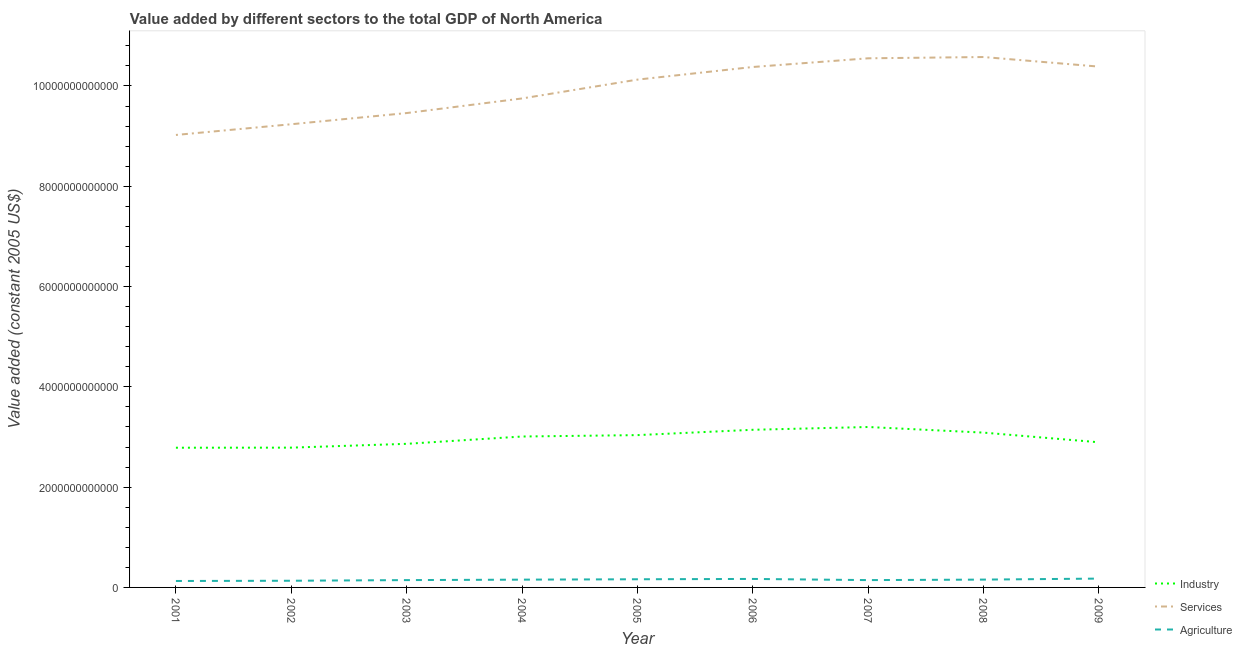Is the number of lines equal to the number of legend labels?
Ensure brevity in your answer.  Yes. What is the value added by services in 2001?
Offer a very short reply. 9.02e+12. Across all years, what is the maximum value added by services?
Make the answer very short. 1.06e+13. Across all years, what is the minimum value added by services?
Provide a short and direct response. 9.02e+12. In which year was the value added by services maximum?
Your answer should be very brief. 2008. In which year was the value added by services minimum?
Give a very brief answer. 2001. What is the total value added by agricultural sector in the graph?
Give a very brief answer. 1.37e+12. What is the difference between the value added by agricultural sector in 2005 and that in 2006?
Keep it short and to the point. -6.64e+09. What is the difference between the value added by agricultural sector in 2008 and the value added by industrial sector in 2009?
Provide a short and direct response. -2.74e+12. What is the average value added by agricultural sector per year?
Keep it short and to the point. 1.53e+11. In the year 2008, what is the difference between the value added by agricultural sector and value added by industrial sector?
Provide a succinct answer. -2.93e+12. What is the ratio of the value added by agricultural sector in 2002 to that in 2009?
Provide a succinct answer. 0.76. Is the value added by agricultural sector in 2001 less than that in 2004?
Give a very brief answer. Yes. What is the difference between the highest and the second highest value added by agricultural sector?
Give a very brief answer. 6.85e+09. What is the difference between the highest and the lowest value added by services?
Offer a terse response. 1.55e+12. Does the value added by industrial sector monotonically increase over the years?
Your answer should be compact. No. Is the value added by services strictly greater than the value added by industrial sector over the years?
Your answer should be compact. Yes. Is the value added by industrial sector strictly less than the value added by agricultural sector over the years?
Give a very brief answer. No. How many years are there in the graph?
Offer a very short reply. 9. What is the difference between two consecutive major ticks on the Y-axis?
Provide a succinct answer. 2.00e+12. Are the values on the major ticks of Y-axis written in scientific E-notation?
Your answer should be compact. No. Where does the legend appear in the graph?
Make the answer very short. Bottom right. How many legend labels are there?
Your answer should be very brief. 3. What is the title of the graph?
Make the answer very short. Value added by different sectors to the total GDP of North America. Does "Ages 50+" appear as one of the legend labels in the graph?
Your response must be concise. No. What is the label or title of the Y-axis?
Your answer should be compact. Value added (constant 2005 US$). What is the Value added (constant 2005 US$) of Industry in 2001?
Offer a terse response. 2.79e+12. What is the Value added (constant 2005 US$) in Services in 2001?
Your response must be concise. 9.02e+12. What is the Value added (constant 2005 US$) of Agriculture in 2001?
Your answer should be compact. 1.28e+11. What is the Value added (constant 2005 US$) in Industry in 2002?
Give a very brief answer. 2.79e+12. What is the Value added (constant 2005 US$) of Services in 2002?
Give a very brief answer. 9.24e+12. What is the Value added (constant 2005 US$) in Agriculture in 2002?
Your answer should be very brief. 1.33e+11. What is the Value added (constant 2005 US$) of Industry in 2003?
Provide a short and direct response. 2.86e+12. What is the Value added (constant 2005 US$) in Services in 2003?
Give a very brief answer. 9.46e+12. What is the Value added (constant 2005 US$) in Agriculture in 2003?
Your answer should be compact. 1.46e+11. What is the Value added (constant 2005 US$) in Industry in 2004?
Provide a short and direct response. 3.01e+12. What is the Value added (constant 2005 US$) of Services in 2004?
Provide a succinct answer. 9.75e+12. What is the Value added (constant 2005 US$) of Agriculture in 2004?
Your answer should be compact. 1.55e+11. What is the Value added (constant 2005 US$) of Industry in 2005?
Offer a very short reply. 3.04e+12. What is the Value added (constant 2005 US$) of Services in 2005?
Your response must be concise. 1.01e+13. What is the Value added (constant 2005 US$) of Agriculture in 2005?
Make the answer very short. 1.63e+11. What is the Value added (constant 2005 US$) of Industry in 2006?
Make the answer very short. 3.14e+12. What is the Value added (constant 2005 US$) of Services in 2006?
Ensure brevity in your answer.  1.04e+13. What is the Value added (constant 2005 US$) in Agriculture in 2006?
Offer a terse response. 1.69e+11. What is the Value added (constant 2005 US$) in Industry in 2007?
Your answer should be very brief. 3.20e+12. What is the Value added (constant 2005 US$) in Services in 2007?
Provide a short and direct response. 1.06e+13. What is the Value added (constant 2005 US$) of Agriculture in 2007?
Give a very brief answer. 1.46e+11. What is the Value added (constant 2005 US$) of Industry in 2008?
Make the answer very short. 3.09e+12. What is the Value added (constant 2005 US$) in Services in 2008?
Offer a very short reply. 1.06e+13. What is the Value added (constant 2005 US$) of Agriculture in 2008?
Your answer should be compact. 1.56e+11. What is the Value added (constant 2005 US$) of Industry in 2009?
Offer a very short reply. 2.89e+12. What is the Value added (constant 2005 US$) in Services in 2009?
Provide a succinct answer. 1.04e+13. What is the Value added (constant 2005 US$) in Agriculture in 2009?
Give a very brief answer. 1.76e+11. Across all years, what is the maximum Value added (constant 2005 US$) in Industry?
Provide a succinct answer. 3.20e+12. Across all years, what is the maximum Value added (constant 2005 US$) in Services?
Your answer should be compact. 1.06e+13. Across all years, what is the maximum Value added (constant 2005 US$) of Agriculture?
Offer a very short reply. 1.76e+11. Across all years, what is the minimum Value added (constant 2005 US$) of Industry?
Your response must be concise. 2.79e+12. Across all years, what is the minimum Value added (constant 2005 US$) in Services?
Make the answer very short. 9.02e+12. Across all years, what is the minimum Value added (constant 2005 US$) in Agriculture?
Provide a short and direct response. 1.28e+11. What is the total Value added (constant 2005 US$) of Industry in the graph?
Offer a terse response. 2.68e+13. What is the total Value added (constant 2005 US$) in Services in the graph?
Offer a very short reply. 8.95e+13. What is the total Value added (constant 2005 US$) of Agriculture in the graph?
Your response must be concise. 1.37e+12. What is the difference between the Value added (constant 2005 US$) in Industry in 2001 and that in 2002?
Keep it short and to the point. -1.61e+09. What is the difference between the Value added (constant 2005 US$) in Services in 2001 and that in 2002?
Your answer should be very brief. -2.14e+11. What is the difference between the Value added (constant 2005 US$) of Agriculture in 2001 and that in 2002?
Offer a very short reply. -4.83e+09. What is the difference between the Value added (constant 2005 US$) of Industry in 2001 and that in 2003?
Offer a very short reply. -7.77e+1. What is the difference between the Value added (constant 2005 US$) of Services in 2001 and that in 2003?
Your answer should be compact. -4.37e+11. What is the difference between the Value added (constant 2005 US$) in Agriculture in 2001 and that in 2003?
Ensure brevity in your answer.  -1.77e+1. What is the difference between the Value added (constant 2005 US$) in Industry in 2001 and that in 2004?
Your response must be concise. -2.23e+11. What is the difference between the Value added (constant 2005 US$) of Services in 2001 and that in 2004?
Keep it short and to the point. -7.28e+11. What is the difference between the Value added (constant 2005 US$) in Agriculture in 2001 and that in 2004?
Provide a short and direct response. -2.69e+1. What is the difference between the Value added (constant 2005 US$) in Industry in 2001 and that in 2005?
Provide a short and direct response. -2.51e+11. What is the difference between the Value added (constant 2005 US$) of Services in 2001 and that in 2005?
Keep it short and to the point. -1.10e+12. What is the difference between the Value added (constant 2005 US$) in Agriculture in 2001 and that in 2005?
Give a very brief answer. -3.43e+1. What is the difference between the Value added (constant 2005 US$) of Industry in 2001 and that in 2006?
Make the answer very short. -3.58e+11. What is the difference between the Value added (constant 2005 US$) of Services in 2001 and that in 2006?
Your answer should be very brief. -1.36e+12. What is the difference between the Value added (constant 2005 US$) in Agriculture in 2001 and that in 2006?
Your answer should be compact. -4.10e+1. What is the difference between the Value added (constant 2005 US$) in Industry in 2001 and that in 2007?
Give a very brief answer. -4.13e+11. What is the difference between the Value added (constant 2005 US$) of Services in 2001 and that in 2007?
Your answer should be compact. -1.53e+12. What is the difference between the Value added (constant 2005 US$) in Agriculture in 2001 and that in 2007?
Make the answer very short. -1.78e+1. What is the difference between the Value added (constant 2005 US$) of Industry in 2001 and that in 2008?
Your answer should be very brief. -3.01e+11. What is the difference between the Value added (constant 2005 US$) in Services in 2001 and that in 2008?
Offer a very short reply. -1.55e+12. What is the difference between the Value added (constant 2005 US$) of Agriculture in 2001 and that in 2008?
Offer a very short reply. -2.77e+1. What is the difference between the Value added (constant 2005 US$) in Industry in 2001 and that in 2009?
Your response must be concise. -1.09e+11. What is the difference between the Value added (constant 2005 US$) in Services in 2001 and that in 2009?
Make the answer very short. -1.36e+12. What is the difference between the Value added (constant 2005 US$) in Agriculture in 2001 and that in 2009?
Your response must be concise. -4.78e+1. What is the difference between the Value added (constant 2005 US$) of Industry in 2002 and that in 2003?
Keep it short and to the point. -7.61e+1. What is the difference between the Value added (constant 2005 US$) of Services in 2002 and that in 2003?
Offer a terse response. -2.23e+11. What is the difference between the Value added (constant 2005 US$) in Agriculture in 2002 and that in 2003?
Your response must be concise. -1.29e+1. What is the difference between the Value added (constant 2005 US$) in Industry in 2002 and that in 2004?
Keep it short and to the point. -2.22e+11. What is the difference between the Value added (constant 2005 US$) in Services in 2002 and that in 2004?
Give a very brief answer. -5.14e+11. What is the difference between the Value added (constant 2005 US$) in Agriculture in 2002 and that in 2004?
Keep it short and to the point. -2.20e+1. What is the difference between the Value added (constant 2005 US$) of Industry in 2002 and that in 2005?
Keep it short and to the point. -2.50e+11. What is the difference between the Value added (constant 2005 US$) in Services in 2002 and that in 2005?
Ensure brevity in your answer.  -8.90e+11. What is the difference between the Value added (constant 2005 US$) in Agriculture in 2002 and that in 2005?
Offer a very short reply. -2.95e+1. What is the difference between the Value added (constant 2005 US$) of Industry in 2002 and that in 2006?
Provide a succinct answer. -3.56e+11. What is the difference between the Value added (constant 2005 US$) of Services in 2002 and that in 2006?
Give a very brief answer. -1.14e+12. What is the difference between the Value added (constant 2005 US$) of Agriculture in 2002 and that in 2006?
Provide a succinct answer. -3.61e+1. What is the difference between the Value added (constant 2005 US$) in Industry in 2002 and that in 2007?
Your answer should be very brief. -4.12e+11. What is the difference between the Value added (constant 2005 US$) of Services in 2002 and that in 2007?
Offer a terse response. -1.31e+12. What is the difference between the Value added (constant 2005 US$) of Agriculture in 2002 and that in 2007?
Give a very brief answer. -1.29e+1. What is the difference between the Value added (constant 2005 US$) of Industry in 2002 and that in 2008?
Offer a terse response. -3.00e+11. What is the difference between the Value added (constant 2005 US$) in Services in 2002 and that in 2008?
Give a very brief answer. -1.34e+12. What is the difference between the Value added (constant 2005 US$) in Agriculture in 2002 and that in 2008?
Give a very brief answer. -2.28e+1. What is the difference between the Value added (constant 2005 US$) in Industry in 2002 and that in 2009?
Offer a very short reply. -1.07e+11. What is the difference between the Value added (constant 2005 US$) of Services in 2002 and that in 2009?
Offer a terse response. -1.15e+12. What is the difference between the Value added (constant 2005 US$) in Agriculture in 2002 and that in 2009?
Your response must be concise. -4.30e+1. What is the difference between the Value added (constant 2005 US$) in Industry in 2003 and that in 2004?
Keep it short and to the point. -1.46e+11. What is the difference between the Value added (constant 2005 US$) of Services in 2003 and that in 2004?
Make the answer very short. -2.91e+11. What is the difference between the Value added (constant 2005 US$) of Agriculture in 2003 and that in 2004?
Offer a very short reply. -9.17e+09. What is the difference between the Value added (constant 2005 US$) in Industry in 2003 and that in 2005?
Offer a terse response. -1.74e+11. What is the difference between the Value added (constant 2005 US$) of Services in 2003 and that in 2005?
Make the answer very short. -6.67e+11. What is the difference between the Value added (constant 2005 US$) of Agriculture in 2003 and that in 2005?
Offer a very short reply. -1.66e+1. What is the difference between the Value added (constant 2005 US$) of Industry in 2003 and that in 2006?
Your answer should be compact. -2.80e+11. What is the difference between the Value added (constant 2005 US$) of Services in 2003 and that in 2006?
Your answer should be very brief. -9.19e+11. What is the difference between the Value added (constant 2005 US$) of Agriculture in 2003 and that in 2006?
Provide a short and direct response. -2.33e+1. What is the difference between the Value added (constant 2005 US$) in Industry in 2003 and that in 2007?
Your answer should be compact. -3.36e+11. What is the difference between the Value added (constant 2005 US$) of Services in 2003 and that in 2007?
Provide a succinct answer. -1.09e+12. What is the difference between the Value added (constant 2005 US$) of Agriculture in 2003 and that in 2007?
Offer a very short reply. -6.44e+07. What is the difference between the Value added (constant 2005 US$) of Industry in 2003 and that in 2008?
Give a very brief answer. -2.24e+11. What is the difference between the Value added (constant 2005 US$) in Services in 2003 and that in 2008?
Ensure brevity in your answer.  -1.12e+12. What is the difference between the Value added (constant 2005 US$) in Agriculture in 2003 and that in 2008?
Provide a succinct answer. -9.98e+09. What is the difference between the Value added (constant 2005 US$) in Industry in 2003 and that in 2009?
Your answer should be very brief. -3.10e+1. What is the difference between the Value added (constant 2005 US$) in Services in 2003 and that in 2009?
Offer a terse response. -9.26e+11. What is the difference between the Value added (constant 2005 US$) in Agriculture in 2003 and that in 2009?
Make the answer very short. -3.01e+1. What is the difference between the Value added (constant 2005 US$) of Industry in 2004 and that in 2005?
Make the answer very short. -2.79e+1. What is the difference between the Value added (constant 2005 US$) of Services in 2004 and that in 2005?
Keep it short and to the point. -3.76e+11. What is the difference between the Value added (constant 2005 US$) in Agriculture in 2004 and that in 2005?
Your answer should be very brief. -7.46e+09. What is the difference between the Value added (constant 2005 US$) of Industry in 2004 and that in 2006?
Offer a very short reply. -1.34e+11. What is the difference between the Value added (constant 2005 US$) in Services in 2004 and that in 2006?
Make the answer very short. -6.27e+11. What is the difference between the Value added (constant 2005 US$) in Agriculture in 2004 and that in 2006?
Ensure brevity in your answer.  -1.41e+1. What is the difference between the Value added (constant 2005 US$) of Industry in 2004 and that in 2007?
Your answer should be very brief. -1.90e+11. What is the difference between the Value added (constant 2005 US$) in Services in 2004 and that in 2007?
Ensure brevity in your answer.  -8.01e+11. What is the difference between the Value added (constant 2005 US$) of Agriculture in 2004 and that in 2007?
Your answer should be very brief. 9.11e+09. What is the difference between the Value added (constant 2005 US$) of Industry in 2004 and that in 2008?
Your response must be concise. -7.78e+1. What is the difference between the Value added (constant 2005 US$) in Services in 2004 and that in 2008?
Offer a very short reply. -8.26e+11. What is the difference between the Value added (constant 2005 US$) in Agriculture in 2004 and that in 2008?
Offer a terse response. -8.08e+08. What is the difference between the Value added (constant 2005 US$) in Industry in 2004 and that in 2009?
Give a very brief answer. 1.15e+11. What is the difference between the Value added (constant 2005 US$) in Services in 2004 and that in 2009?
Ensure brevity in your answer.  -6.35e+11. What is the difference between the Value added (constant 2005 US$) of Agriculture in 2004 and that in 2009?
Your answer should be very brief. -2.09e+1. What is the difference between the Value added (constant 2005 US$) of Industry in 2005 and that in 2006?
Offer a terse response. -1.06e+11. What is the difference between the Value added (constant 2005 US$) of Services in 2005 and that in 2006?
Give a very brief answer. -2.52e+11. What is the difference between the Value added (constant 2005 US$) in Agriculture in 2005 and that in 2006?
Your answer should be very brief. -6.64e+09. What is the difference between the Value added (constant 2005 US$) of Industry in 2005 and that in 2007?
Make the answer very short. -1.62e+11. What is the difference between the Value added (constant 2005 US$) in Services in 2005 and that in 2007?
Offer a terse response. -4.25e+11. What is the difference between the Value added (constant 2005 US$) in Agriculture in 2005 and that in 2007?
Your response must be concise. 1.66e+1. What is the difference between the Value added (constant 2005 US$) in Industry in 2005 and that in 2008?
Your answer should be compact. -5.00e+1. What is the difference between the Value added (constant 2005 US$) of Services in 2005 and that in 2008?
Offer a very short reply. -4.51e+11. What is the difference between the Value added (constant 2005 US$) of Agriculture in 2005 and that in 2008?
Your answer should be very brief. 6.65e+09. What is the difference between the Value added (constant 2005 US$) in Industry in 2005 and that in 2009?
Your answer should be very brief. 1.43e+11. What is the difference between the Value added (constant 2005 US$) of Services in 2005 and that in 2009?
Offer a terse response. -2.60e+11. What is the difference between the Value added (constant 2005 US$) of Agriculture in 2005 and that in 2009?
Your response must be concise. -1.35e+1. What is the difference between the Value added (constant 2005 US$) in Industry in 2006 and that in 2007?
Give a very brief answer. -5.56e+1. What is the difference between the Value added (constant 2005 US$) in Services in 2006 and that in 2007?
Your response must be concise. -1.73e+11. What is the difference between the Value added (constant 2005 US$) in Agriculture in 2006 and that in 2007?
Make the answer very short. 2.32e+1. What is the difference between the Value added (constant 2005 US$) of Industry in 2006 and that in 2008?
Provide a short and direct response. 5.63e+1. What is the difference between the Value added (constant 2005 US$) of Services in 2006 and that in 2008?
Provide a short and direct response. -1.99e+11. What is the difference between the Value added (constant 2005 US$) in Agriculture in 2006 and that in 2008?
Offer a very short reply. 1.33e+1. What is the difference between the Value added (constant 2005 US$) in Industry in 2006 and that in 2009?
Provide a short and direct response. 2.49e+11. What is the difference between the Value added (constant 2005 US$) of Services in 2006 and that in 2009?
Your answer should be very brief. -7.72e+09. What is the difference between the Value added (constant 2005 US$) in Agriculture in 2006 and that in 2009?
Offer a terse response. -6.85e+09. What is the difference between the Value added (constant 2005 US$) of Industry in 2007 and that in 2008?
Your response must be concise. 1.12e+11. What is the difference between the Value added (constant 2005 US$) in Services in 2007 and that in 2008?
Give a very brief answer. -2.54e+1. What is the difference between the Value added (constant 2005 US$) of Agriculture in 2007 and that in 2008?
Offer a very short reply. -9.92e+09. What is the difference between the Value added (constant 2005 US$) in Industry in 2007 and that in 2009?
Make the answer very short. 3.05e+11. What is the difference between the Value added (constant 2005 US$) of Services in 2007 and that in 2009?
Provide a short and direct response. 1.66e+11. What is the difference between the Value added (constant 2005 US$) in Agriculture in 2007 and that in 2009?
Provide a succinct answer. -3.01e+1. What is the difference between the Value added (constant 2005 US$) in Industry in 2008 and that in 2009?
Your answer should be very brief. 1.93e+11. What is the difference between the Value added (constant 2005 US$) in Services in 2008 and that in 2009?
Offer a terse response. 1.91e+11. What is the difference between the Value added (constant 2005 US$) of Agriculture in 2008 and that in 2009?
Provide a succinct answer. -2.01e+1. What is the difference between the Value added (constant 2005 US$) of Industry in 2001 and the Value added (constant 2005 US$) of Services in 2002?
Keep it short and to the point. -6.45e+12. What is the difference between the Value added (constant 2005 US$) in Industry in 2001 and the Value added (constant 2005 US$) in Agriculture in 2002?
Ensure brevity in your answer.  2.65e+12. What is the difference between the Value added (constant 2005 US$) in Services in 2001 and the Value added (constant 2005 US$) in Agriculture in 2002?
Provide a short and direct response. 8.89e+12. What is the difference between the Value added (constant 2005 US$) in Industry in 2001 and the Value added (constant 2005 US$) in Services in 2003?
Your response must be concise. -6.67e+12. What is the difference between the Value added (constant 2005 US$) in Industry in 2001 and the Value added (constant 2005 US$) in Agriculture in 2003?
Make the answer very short. 2.64e+12. What is the difference between the Value added (constant 2005 US$) of Services in 2001 and the Value added (constant 2005 US$) of Agriculture in 2003?
Provide a short and direct response. 8.88e+12. What is the difference between the Value added (constant 2005 US$) in Industry in 2001 and the Value added (constant 2005 US$) in Services in 2004?
Provide a short and direct response. -6.97e+12. What is the difference between the Value added (constant 2005 US$) of Industry in 2001 and the Value added (constant 2005 US$) of Agriculture in 2004?
Keep it short and to the point. 2.63e+12. What is the difference between the Value added (constant 2005 US$) in Services in 2001 and the Value added (constant 2005 US$) in Agriculture in 2004?
Your answer should be very brief. 8.87e+12. What is the difference between the Value added (constant 2005 US$) of Industry in 2001 and the Value added (constant 2005 US$) of Services in 2005?
Ensure brevity in your answer.  -7.34e+12. What is the difference between the Value added (constant 2005 US$) of Industry in 2001 and the Value added (constant 2005 US$) of Agriculture in 2005?
Your answer should be very brief. 2.62e+12. What is the difference between the Value added (constant 2005 US$) in Services in 2001 and the Value added (constant 2005 US$) in Agriculture in 2005?
Ensure brevity in your answer.  8.86e+12. What is the difference between the Value added (constant 2005 US$) of Industry in 2001 and the Value added (constant 2005 US$) of Services in 2006?
Give a very brief answer. -7.59e+12. What is the difference between the Value added (constant 2005 US$) in Industry in 2001 and the Value added (constant 2005 US$) in Agriculture in 2006?
Your answer should be compact. 2.62e+12. What is the difference between the Value added (constant 2005 US$) in Services in 2001 and the Value added (constant 2005 US$) in Agriculture in 2006?
Offer a terse response. 8.85e+12. What is the difference between the Value added (constant 2005 US$) in Industry in 2001 and the Value added (constant 2005 US$) in Services in 2007?
Provide a short and direct response. -7.77e+12. What is the difference between the Value added (constant 2005 US$) in Industry in 2001 and the Value added (constant 2005 US$) in Agriculture in 2007?
Offer a very short reply. 2.64e+12. What is the difference between the Value added (constant 2005 US$) in Services in 2001 and the Value added (constant 2005 US$) in Agriculture in 2007?
Your answer should be compact. 8.88e+12. What is the difference between the Value added (constant 2005 US$) in Industry in 2001 and the Value added (constant 2005 US$) in Services in 2008?
Your answer should be very brief. -7.79e+12. What is the difference between the Value added (constant 2005 US$) in Industry in 2001 and the Value added (constant 2005 US$) in Agriculture in 2008?
Offer a terse response. 2.63e+12. What is the difference between the Value added (constant 2005 US$) of Services in 2001 and the Value added (constant 2005 US$) of Agriculture in 2008?
Offer a terse response. 8.87e+12. What is the difference between the Value added (constant 2005 US$) in Industry in 2001 and the Value added (constant 2005 US$) in Services in 2009?
Give a very brief answer. -7.60e+12. What is the difference between the Value added (constant 2005 US$) in Industry in 2001 and the Value added (constant 2005 US$) in Agriculture in 2009?
Make the answer very short. 2.61e+12. What is the difference between the Value added (constant 2005 US$) in Services in 2001 and the Value added (constant 2005 US$) in Agriculture in 2009?
Make the answer very short. 8.85e+12. What is the difference between the Value added (constant 2005 US$) of Industry in 2002 and the Value added (constant 2005 US$) of Services in 2003?
Ensure brevity in your answer.  -6.67e+12. What is the difference between the Value added (constant 2005 US$) in Industry in 2002 and the Value added (constant 2005 US$) in Agriculture in 2003?
Keep it short and to the point. 2.64e+12. What is the difference between the Value added (constant 2005 US$) in Services in 2002 and the Value added (constant 2005 US$) in Agriculture in 2003?
Your answer should be very brief. 9.09e+12. What is the difference between the Value added (constant 2005 US$) in Industry in 2002 and the Value added (constant 2005 US$) in Services in 2004?
Make the answer very short. -6.96e+12. What is the difference between the Value added (constant 2005 US$) of Industry in 2002 and the Value added (constant 2005 US$) of Agriculture in 2004?
Make the answer very short. 2.63e+12. What is the difference between the Value added (constant 2005 US$) of Services in 2002 and the Value added (constant 2005 US$) of Agriculture in 2004?
Your response must be concise. 9.08e+12. What is the difference between the Value added (constant 2005 US$) of Industry in 2002 and the Value added (constant 2005 US$) of Services in 2005?
Your response must be concise. -7.34e+12. What is the difference between the Value added (constant 2005 US$) of Industry in 2002 and the Value added (constant 2005 US$) of Agriculture in 2005?
Offer a terse response. 2.63e+12. What is the difference between the Value added (constant 2005 US$) of Services in 2002 and the Value added (constant 2005 US$) of Agriculture in 2005?
Keep it short and to the point. 9.07e+12. What is the difference between the Value added (constant 2005 US$) of Industry in 2002 and the Value added (constant 2005 US$) of Services in 2006?
Ensure brevity in your answer.  -7.59e+12. What is the difference between the Value added (constant 2005 US$) in Industry in 2002 and the Value added (constant 2005 US$) in Agriculture in 2006?
Ensure brevity in your answer.  2.62e+12. What is the difference between the Value added (constant 2005 US$) of Services in 2002 and the Value added (constant 2005 US$) of Agriculture in 2006?
Provide a succinct answer. 9.07e+12. What is the difference between the Value added (constant 2005 US$) in Industry in 2002 and the Value added (constant 2005 US$) in Services in 2007?
Give a very brief answer. -7.76e+12. What is the difference between the Value added (constant 2005 US$) of Industry in 2002 and the Value added (constant 2005 US$) of Agriculture in 2007?
Make the answer very short. 2.64e+12. What is the difference between the Value added (constant 2005 US$) of Services in 2002 and the Value added (constant 2005 US$) of Agriculture in 2007?
Offer a terse response. 9.09e+12. What is the difference between the Value added (constant 2005 US$) in Industry in 2002 and the Value added (constant 2005 US$) in Services in 2008?
Offer a very short reply. -7.79e+12. What is the difference between the Value added (constant 2005 US$) of Industry in 2002 and the Value added (constant 2005 US$) of Agriculture in 2008?
Your answer should be very brief. 2.63e+12. What is the difference between the Value added (constant 2005 US$) of Services in 2002 and the Value added (constant 2005 US$) of Agriculture in 2008?
Offer a terse response. 9.08e+12. What is the difference between the Value added (constant 2005 US$) in Industry in 2002 and the Value added (constant 2005 US$) in Services in 2009?
Your answer should be very brief. -7.60e+12. What is the difference between the Value added (constant 2005 US$) of Industry in 2002 and the Value added (constant 2005 US$) of Agriculture in 2009?
Your response must be concise. 2.61e+12. What is the difference between the Value added (constant 2005 US$) of Services in 2002 and the Value added (constant 2005 US$) of Agriculture in 2009?
Keep it short and to the point. 9.06e+12. What is the difference between the Value added (constant 2005 US$) of Industry in 2003 and the Value added (constant 2005 US$) of Services in 2004?
Offer a very short reply. -6.89e+12. What is the difference between the Value added (constant 2005 US$) of Industry in 2003 and the Value added (constant 2005 US$) of Agriculture in 2004?
Offer a terse response. 2.71e+12. What is the difference between the Value added (constant 2005 US$) in Services in 2003 and the Value added (constant 2005 US$) in Agriculture in 2004?
Offer a terse response. 9.30e+12. What is the difference between the Value added (constant 2005 US$) in Industry in 2003 and the Value added (constant 2005 US$) in Services in 2005?
Offer a very short reply. -7.26e+12. What is the difference between the Value added (constant 2005 US$) of Industry in 2003 and the Value added (constant 2005 US$) of Agriculture in 2005?
Keep it short and to the point. 2.70e+12. What is the difference between the Value added (constant 2005 US$) of Services in 2003 and the Value added (constant 2005 US$) of Agriculture in 2005?
Make the answer very short. 9.30e+12. What is the difference between the Value added (constant 2005 US$) of Industry in 2003 and the Value added (constant 2005 US$) of Services in 2006?
Provide a succinct answer. -7.51e+12. What is the difference between the Value added (constant 2005 US$) of Industry in 2003 and the Value added (constant 2005 US$) of Agriculture in 2006?
Offer a terse response. 2.69e+12. What is the difference between the Value added (constant 2005 US$) of Services in 2003 and the Value added (constant 2005 US$) of Agriculture in 2006?
Offer a terse response. 9.29e+12. What is the difference between the Value added (constant 2005 US$) in Industry in 2003 and the Value added (constant 2005 US$) in Services in 2007?
Ensure brevity in your answer.  -7.69e+12. What is the difference between the Value added (constant 2005 US$) of Industry in 2003 and the Value added (constant 2005 US$) of Agriculture in 2007?
Give a very brief answer. 2.72e+12. What is the difference between the Value added (constant 2005 US$) in Services in 2003 and the Value added (constant 2005 US$) in Agriculture in 2007?
Make the answer very short. 9.31e+12. What is the difference between the Value added (constant 2005 US$) of Industry in 2003 and the Value added (constant 2005 US$) of Services in 2008?
Your response must be concise. -7.71e+12. What is the difference between the Value added (constant 2005 US$) of Industry in 2003 and the Value added (constant 2005 US$) of Agriculture in 2008?
Your answer should be very brief. 2.71e+12. What is the difference between the Value added (constant 2005 US$) of Services in 2003 and the Value added (constant 2005 US$) of Agriculture in 2008?
Your answer should be very brief. 9.30e+12. What is the difference between the Value added (constant 2005 US$) of Industry in 2003 and the Value added (constant 2005 US$) of Services in 2009?
Provide a succinct answer. -7.52e+12. What is the difference between the Value added (constant 2005 US$) in Industry in 2003 and the Value added (constant 2005 US$) in Agriculture in 2009?
Provide a short and direct response. 2.69e+12. What is the difference between the Value added (constant 2005 US$) of Services in 2003 and the Value added (constant 2005 US$) of Agriculture in 2009?
Offer a terse response. 9.28e+12. What is the difference between the Value added (constant 2005 US$) in Industry in 2004 and the Value added (constant 2005 US$) in Services in 2005?
Your response must be concise. -7.12e+12. What is the difference between the Value added (constant 2005 US$) of Industry in 2004 and the Value added (constant 2005 US$) of Agriculture in 2005?
Provide a succinct answer. 2.85e+12. What is the difference between the Value added (constant 2005 US$) of Services in 2004 and the Value added (constant 2005 US$) of Agriculture in 2005?
Keep it short and to the point. 9.59e+12. What is the difference between the Value added (constant 2005 US$) in Industry in 2004 and the Value added (constant 2005 US$) in Services in 2006?
Your response must be concise. -7.37e+12. What is the difference between the Value added (constant 2005 US$) of Industry in 2004 and the Value added (constant 2005 US$) of Agriculture in 2006?
Ensure brevity in your answer.  2.84e+12. What is the difference between the Value added (constant 2005 US$) in Services in 2004 and the Value added (constant 2005 US$) in Agriculture in 2006?
Your response must be concise. 9.58e+12. What is the difference between the Value added (constant 2005 US$) in Industry in 2004 and the Value added (constant 2005 US$) in Services in 2007?
Give a very brief answer. -7.54e+12. What is the difference between the Value added (constant 2005 US$) in Industry in 2004 and the Value added (constant 2005 US$) in Agriculture in 2007?
Offer a very short reply. 2.86e+12. What is the difference between the Value added (constant 2005 US$) in Services in 2004 and the Value added (constant 2005 US$) in Agriculture in 2007?
Your answer should be very brief. 9.61e+12. What is the difference between the Value added (constant 2005 US$) in Industry in 2004 and the Value added (constant 2005 US$) in Services in 2008?
Offer a terse response. -7.57e+12. What is the difference between the Value added (constant 2005 US$) of Industry in 2004 and the Value added (constant 2005 US$) of Agriculture in 2008?
Your response must be concise. 2.85e+12. What is the difference between the Value added (constant 2005 US$) in Services in 2004 and the Value added (constant 2005 US$) in Agriculture in 2008?
Give a very brief answer. 9.60e+12. What is the difference between the Value added (constant 2005 US$) in Industry in 2004 and the Value added (constant 2005 US$) in Services in 2009?
Make the answer very short. -7.38e+12. What is the difference between the Value added (constant 2005 US$) in Industry in 2004 and the Value added (constant 2005 US$) in Agriculture in 2009?
Ensure brevity in your answer.  2.83e+12. What is the difference between the Value added (constant 2005 US$) in Services in 2004 and the Value added (constant 2005 US$) in Agriculture in 2009?
Your answer should be compact. 9.58e+12. What is the difference between the Value added (constant 2005 US$) in Industry in 2005 and the Value added (constant 2005 US$) in Services in 2006?
Keep it short and to the point. -7.34e+12. What is the difference between the Value added (constant 2005 US$) in Industry in 2005 and the Value added (constant 2005 US$) in Agriculture in 2006?
Ensure brevity in your answer.  2.87e+12. What is the difference between the Value added (constant 2005 US$) in Services in 2005 and the Value added (constant 2005 US$) in Agriculture in 2006?
Your response must be concise. 9.96e+12. What is the difference between the Value added (constant 2005 US$) in Industry in 2005 and the Value added (constant 2005 US$) in Services in 2007?
Offer a very short reply. -7.51e+12. What is the difference between the Value added (constant 2005 US$) in Industry in 2005 and the Value added (constant 2005 US$) in Agriculture in 2007?
Provide a short and direct response. 2.89e+12. What is the difference between the Value added (constant 2005 US$) of Services in 2005 and the Value added (constant 2005 US$) of Agriculture in 2007?
Provide a succinct answer. 9.98e+12. What is the difference between the Value added (constant 2005 US$) of Industry in 2005 and the Value added (constant 2005 US$) of Services in 2008?
Keep it short and to the point. -7.54e+12. What is the difference between the Value added (constant 2005 US$) in Industry in 2005 and the Value added (constant 2005 US$) in Agriculture in 2008?
Ensure brevity in your answer.  2.88e+12. What is the difference between the Value added (constant 2005 US$) of Services in 2005 and the Value added (constant 2005 US$) of Agriculture in 2008?
Ensure brevity in your answer.  9.97e+12. What is the difference between the Value added (constant 2005 US$) in Industry in 2005 and the Value added (constant 2005 US$) in Services in 2009?
Ensure brevity in your answer.  -7.35e+12. What is the difference between the Value added (constant 2005 US$) in Industry in 2005 and the Value added (constant 2005 US$) in Agriculture in 2009?
Offer a very short reply. 2.86e+12. What is the difference between the Value added (constant 2005 US$) in Services in 2005 and the Value added (constant 2005 US$) in Agriculture in 2009?
Provide a short and direct response. 9.95e+12. What is the difference between the Value added (constant 2005 US$) of Industry in 2006 and the Value added (constant 2005 US$) of Services in 2007?
Give a very brief answer. -7.41e+12. What is the difference between the Value added (constant 2005 US$) of Industry in 2006 and the Value added (constant 2005 US$) of Agriculture in 2007?
Ensure brevity in your answer.  3.00e+12. What is the difference between the Value added (constant 2005 US$) of Services in 2006 and the Value added (constant 2005 US$) of Agriculture in 2007?
Ensure brevity in your answer.  1.02e+13. What is the difference between the Value added (constant 2005 US$) in Industry in 2006 and the Value added (constant 2005 US$) in Services in 2008?
Give a very brief answer. -7.43e+12. What is the difference between the Value added (constant 2005 US$) in Industry in 2006 and the Value added (constant 2005 US$) in Agriculture in 2008?
Keep it short and to the point. 2.99e+12. What is the difference between the Value added (constant 2005 US$) of Services in 2006 and the Value added (constant 2005 US$) of Agriculture in 2008?
Offer a very short reply. 1.02e+13. What is the difference between the Value added (constant 2005 US$) of Industry in 2006 and the Value added (constant 2005 US$) of Services in 2009?
Your answer should be compact. -7.24e+12. What is the difference between the Value added (constant 2005 US$) in Industry in 2006 and the Value added (constant 2005 US$) in Agriculture in 2009?
Keep it short and to the point. 2.97e+12. What is the difference between the Value added (constant 2005 US$) in Services in 2006 and the Value added (constant 2005 US$) in Agriculture in 2009?
Make the answer very short. 1.02e+13. What is the difference between the Value added (constant 2005 US$) in Industry in 2007 and the Value added (constant 2005 US$) in Services in 2008?
Give a very brief answer. -7.38e+12. What is the difference between the Value added (constant 2005 US$) in Industry in 2007 and the Value added (constant 2005 US$) in Agriculture in 2008?
Give a very brief answer. 3.04e+12. What is the difference between the Value added (constant 2005 US$) in Services in 2007 and the Value added (constant 2005 US$) in Agriculture in 2008?
Make the answer very short. 1.04e+13. What is the difference between the Value added (constant 2005 US$) in Industry in 2007 and the Value added (constant 2005 US$) in Services in 2009?
Provide a succinct answer. -7.19e+12. What is the difference between the Value added (constant 2005 US$) of Industry in 2007 and the Value added (constant 2005 US$) of Agriculture in 2009?
Offer a very short reply. 3.02e+12. What is the difference between the Value added (constant 2005 US$) of Services in 2007 and the Value added (constant 2005 US$) of Agriculture in 2009?
Make the answer very short. 1.04e+13. What is the difference between the Value added (constant 2005 US$) in Industry in 2008 and the Value added (constant 2005 US$) in Services in 2009?
Offer a terse response. -7.30e+12. What is the difference between the Value added (constant 2005 US$) in Industry in 2008 and the Value added (constant 2005 US$) in Agriculture in 2009?
Provide a succinct answer. 2.91e+12. What is the difference between the Value added (constant 2005 US$) in Services in 2008 and the Value added (constant 2005 US$) in Agriculture in 2009?
Ensure brevity in your answer.  1.04e+13. What is the average Value added (constant 2005 US$) of Industry per year?
Keep it short and to the point. 2.98e+12. What is the average Value added (constant 2005 US$) of Services per year?
Your answer should be very brief. 9.94e+12. What is the average Value added (constant 2005 US$) in Agriculture per year?
Ensure brevity in your answer.  1.53e+11. In the year 2001, what is the difference between the Value added (constant 2005 US$) of Industry and Value added (constant 2005 US$) of Services?
Provide a succinct answer. -6.24e+12. In the year 2001, what is the difference between the Value added (constant 2005 US$) in Industry and Value added (constant 2005 US$) in Agriculture?
Ensure brevity in your answer.  2.66e+12. In the year 2001, what is the difference between the Value added (constant 2005 US$) of Services and Value added (constant 2005 US$) of Agriculture?
Make the answer very short. 8.90e+12. In the year 2002, what is the difference between the Value added (constant 2005 US$) in Industry and Value added (constant 2005 US$) in Services?
Provide a short and direct response. -6.45e+12. In the year 2002, what is the difference between the Value added (constant 2005 US$) in Industry and Value added (constant 2005 US$) in Agriculture?
Ensure brevity in your answer.  2.65e+12. In the year 2002, what is the difference between the Value added (constant 2005 US$) of Services and Value added (constant 2005 US$) of Agriculture?
Provide a succinct answer. 9.10e+12. In the year 2003, what is the difference between the Value added (constant 2005 US$) of Industry and Value added (constant 2005 US$) of Services?
Keep it short and to the point. -6.60e+12. In the year 2003, what is the difference between the Value added (constant 2005 US$) in Industry and Value added (constant 2005 US$) in Agriculture?
Your answer should be compact. 2.72e+12. In the year 2003, what is the difference between the Value added (constant 2005 US$) of Services and Value added (constant 2005 US$) of Agriculture?
Your answer should be compact. 9.31e+12. In the year 2004, what is the difference between the Value added (constant 2005 US$) of Industry and Value added (constant 2005 US$) of Services?
Ensure brevity in your answer.  -6.74e+12. In the year 2004, what is the difference between the Value added (constant 2005 US$) in Industry and Value added (constant 2005 US$) in Agriculture?
Offer a terse response. 2.85e+12. In the year 2004, what is the difference between the Value added (constant 2005 US$) in Services and Value added (constant 2005 US$) in Agriculture?
Your answer should be compact. 9.60e+12. In the year 2005, what is the difference between the Value added (constant 2005 US$) in Industry and Value added (constant 2005 US$) in Services?
Give a very brief answer. -7.09e+12. In the year 2005, what is the difference between the Value added (constant 2005 US$) of Industry and Value added (constant 2005 US$) of Agriculture?
Provide a short and direct response. 2.87e+12. In the year 2005, what is the difference between the Value added (constant 2005 US$) of Services and Value added (constant 2005 US$) of Agriculture?
Provide a succinct answer. 9.96e+12. In the year 2006, what is the difference between the Value added (constant 2005 US$) in Industry and Value added (constant 2005 US$) in Services?
Offer a very short reply. -7.24e+12. In the year 2006, what is the difference between the Value added (constant 2005 US$) of Industry and Value added (constant 2005 US$) of Agriculture?
Ensure brevity in your answer.  2.97e+12. In the year 2006, what is the difference between the Value added (constant 2005 US$) in Services and Value added (constant 2005 US$) in Agriculture?
Provide a short and direct response. 1.02e+13. In the year 2007, what is the difference between the Value added (constant 2005 US$) in Industry and Value added (constant 2005 US$) in Services?
Give a very brief answer. -7.35e+12. In the year 2007, what is the difference between the Value added (constant 2005 US$) in Industry and Value added (constant 2005 US$) in Agriculture?
Your response must be concise. 3.05e+12. In the year 2007, what is the difference between the Value added (constant 2005 US$) of Services and Value added (constant 2005 US$) of Agriculture?
Give a very brief answer. 1.04e+13. In the year 2008, what is the difference between the Value added (constant 2005 US$) of Industry and Value added (constant 2005 US$) of Services?
Provide a succinct answer. -7.49e+12. In the year 2008, what is the difference between the Value added (constant 2005 US$) in Industry and Value added (constant 2005 US$) in Agriculture?
Your answer should be compact. 2.93e+12. In the year 2008, what is the difference between the Value added (constant 2005 US$) of Services and Value added (constant 2005 US$) of Agriculture?
Offer a terse response. 1.04e+13. In the year 2009, what is the difference between the Value added (constant 2005 US$) in Industry and Value added (constant 2005 US$) in Services?
Offer a terse response. -7.49e+12. In the year 2009, what is the difference between the Value added (constant 2005 US$) in Industry and Value added (constant 2005 US$) in Agriculture?
Offer a terse response. 2.72e+12. In the year 2009, what is the difference between the Value added (constant 2005 US$) in Services and Value added (constant 2005 US$) in Agriculture?
Provide a succinct answer. 1.02e+13. What is the ratio of the Value added (constant 2005 US$) in Industry in 2001 to that in 2002?
Your answer should be very brief. 1. What is the ratio of the Value added (constant 2005 US$) of Services in 2001 to that in 2002?
Ensure brevity in your answer.  0.98. What is the ratio of the Value added (constant 2005 US$) of Agriculture in 2001 to that in 2002?
Your response must be concise. 0.96. What is the ratio of the Value added (constant 2005 US$) of Industry in 2001 to that in 2003?
Your answer should be very brief. 0.97. What is the ratio of the Value added (constant 2005 US$) of Services in 2001 to that in 2003?
Keep it short and to the point. 0.95. What is the ratio of the Value added (constant 2005 US$) in Agriculture in 2001 to that in 2003?
Provide a succinct answer. 0.88. What is the ratio of the Value added (constant 2005 US$) in Industry in 2001 to that in 2004?
Give a very brief answer. 0.93. What is the ratio of the Value added (constant 2005 US$) of Services in 2001 to that in 2004?
Your answer should be very brief. 0.93. What is the ratio of the Value added (constant 2005 US$) of Agriculture in 2001 to that in 2004?
Your answer should be very brief. 0.83. What is the ratio of the Value added (constant 2005 US$) in Industry in 2001 to that in 2005?
Your response must be concise. 0.92. What is the ratio of the Value added (constant 2005 US$) of Services in 2001 to that in 2005?
Your answer should be compact. 0.89. What is the ratio of the Value added (constant 2005 US$) of Agriculture in 2001 to that in 2005?
Make the answer very short. 0.79. What is the ratio of the Value added (constant 2005 US$) in Industry in 2001 to that in 2006?
Provide a succinct answer. 0.89. What is the ratio of the Value added (constant 2005 US$) of Services in 2001 to that in 2006?
Your answer should be compact. 0.87. What is the ratio of the Value added (constant 2005 US$) in Agriculture in 2001 to that in 2006?
Your answer should be compact. 0.76. What is the ratio of the Value added (constant 2005 US$) in Industry in 2001 to that in 2007?
Ensure brevity in your answer.  0.87. What is the ratio of the Value added (constant 2005 US$) of Services in 2001 to that in 2007?
Give a very brief answer. 0.86. What is the ratio of the Value added (constant 2005 US$) of Agriculture in 2001 to that in 2007?
Give a very brief answer. 0.88. What is the ratio of the Value added (constant 2005 US$) of Industry in 2001 to that in 2008?
Keep it short and to the point. 0.9. What is the ratio of the Value added (constant 2005 US$) in Services in 2001 to that in 2008?
Give a very brief answer. 0.85. What is the ratio of the Value added (constant 2005 US$) of Agriculture in 2001 to that in 2008?
Offer a terse response. 0.82. What is the ratio of the Value added (constant 2005 US$) of Industry in 2001 to that in 2009?
Offer a very short reply. 0.96. What is the ratio of the Value added (constant 2005 US$) in Services in 2001 to that in 2009?
Offer a very short reply. 0.87. What is the ratio of the Value added (constant 2005 US$) in Agriculture in 2001 to that in 2009?
Your answer should be compact. 0.73. What is the ratio of the Value added (constant 2005 US$) of Industry in 2002 to that in 2003?
Your response must be concise. 0.97. What is the ratio of the Value added (constant 2005 US$) in Services in 2002 to that in 2003?
Your answer should be compact. 0.98. What is the ratio of the Value added (constant 2005 US$) of Agriculture in 2002 to that in 2003?
Your response must be concise. 0.91. What is the ratio of the Value added (constant 2005 US$) in Industry in 2002 to that in 2004?
Offer a terse response. 0.93. What is the ratio of the Value added (constant 2005 US$) in Services in 2002 to that in 2004?
Make the answer very short. 0.95. What is the ratio of the Value added (constant 2005 US$) of Agriculture in 2002 to that in 2004?
Your answer should be compact. 0.86. What is the ratio of the Value added (constant 2005 US$) in Industry in 2002 to that in 2005?
Your answer should be very brief. 0.92. What is the ratio of the Value added (constant 2005 US$) in Services in 2002 to that in 2005?
Your answer should be very brief. 0.91. What is the ratio of the Value added (constant 2005 US$) in Agriculture in 2002 to that in 2005?
Provide a short and direct response. 0.82. What is the ratio of the Value added (constant 2005 US$) of Industry in 2002 to that in 2006?
Ensure brevity in your answer.  0.89. What is the ratio of the Value added (constant 2005 US$) in Services in 2002 to that in 2006?
Keep it short and to the point. 0.89. What is the ratio of the Value added (constant 2005 US$) in Agriculture in 2002 to that in 2006?
Offer a very short reply. 0.79. What is the ratio of the Value added (constant 2005 US$) in Industry in 2002 to that in 2007?
Keep it short and to the point. 0.87. What is the ratio of the Value added (constant 2005 US$) of Services in 2002 to that in 2007?
Make the answer very short. 0.88. What is the ratio of the Value added (constant 2005 US$) of Agriculture in 2002 to that in 2007?
Your answer should be compact. 0.91. What is the ratio of the Value added (constant 2005 US$) of Industry in 2002 to that in 2008?
Offer a very short reply. 0.9. What is the ratio of the Value added (constant 2005 US$) in Services in 2002 to that in 2008?
Provide a succinct answer. 0.87. What is the ratio of the Value added (constant 2005 US$) of Agriculture in 2002 to that in 2008?
Give a very brief answer. 0.85. What is the ratio of the Value added (constant 2005 US$) in Services in 2002 to that in 2009?
Your response must be concise. 0.89. What is the ratio of the Value added (constant 2005 US$) in Agriculture in 2002 to that in 2009?
Give a very brief answer. 0.76. What is the ratio of the Value added (constant 2005 US$) of Industry in 2003 to that in 2004?
Keep it short and to the point. 0.95. What is the ratio of the Value added (constant 2005 US$) of Services in 2003 to that in 2004?
Give a very brief answer. 0.97. What is the ratio of the Value added (constant 2005 US$) in Agriculture in 2003 to that in 2004?
Ensure brevity in your answer.  0.94. What is the ratio of the Value added (constant 2005 US$) of Industry in 2003 to that in 2005?
Provide a succinct answer. 0.94. What is the ratio of the Value added (constant 2005 US$) of Services in 2003 to that in 2005?
Offer a terse response. 0.93. What is the ratio of the Value added (constant 2005 US$) of Agriculture in 2003 to that in 2005?
Give a very brief answer. 0.9. What is the ratio of the Value added (constant 2005 US$) in Industry in 2003 to that in 2006?
Provide a short and direct response. 0.91. What is the ratio of the Value added (constant 2005 US$) in Services in 2003 to that in 2006?
Ensure brevity in your answer.  0.91. What is the ratio of the Value added (constant 2005 US$) in Agriculture in 2003 to that in 2006?
Give a very brief answer. 0.86. What is the ratio of the Value added (constant 2005 US$) in Industry in 2003 to that in 2007?
Your answer should be compact. 0.9. What is the ratio of the Value added (constant 2005 US$) in Services in 2003 to that in 2007?
Keep it short and to the point. 0.9. What is the ratio of the Value added (constant 2005 US$) in Industry in 2003 to that in 2008?
Make the answer very short. 0.93. What is the ratio of the Value added (constant 2005 US$) in Services in 2003 to that in 2008?
Your response must be concise. 0.89. What is the ratio of the Value added (constant 2005 US$) of Agriculture in 2003 to that in 2008?
Provide a succinct answer. 0.94. What is the ratio of the Value added (constant 2005 US$) of Industry in 2003 to that in 2009?
Provide a succinct answer. 0.99. What is the ratio of the Value added (constant 2005 US$) in Services in 2003 to that in 2009?
Provide a succinct answer. 0.91. What is the ratio of the Value added (constant 2005 US$) in Agriculture in 2003 to that in 2009?
Make the answer very short. 0.83. What is the ratio of the Value added (constant 2005 US$) in Services in 2004 to that in 2005?
Ensure brevity in your answer.  0.96. What is the ratio of the Value added (constant 2005 US$) of Agriculture in 2004 to that in 2005?
Give a very brief answer. 0.95. What is the ratio of the Value added (constant 2005 US$) in Industry in 2004 to that in 2006?
Provide a short and direct response. 0.96. What is the ratio of the Value added (constant 2005 US$) in Services in 2004 to that in 2006?
Provide a short and direct response. 0.94. What is the ratio of the Value added (constant 2005 US$) in Agriculture in 2004 to that in 2006?
Keep it short and to the point. 0.92. What is the ratio of the Value added (constant 2005 US$) of Industry in 2004 to that in 2007?
Offer a very short reply. 0.94. What is the ratio of the Value added (constant 2005 US$) in Services in 2004 to that in 2007?
Provide a short and direct response. 0.92. What is the ratio of the Value added (constant 2005 US$) in Agriculture in 2004 to that in 2007?
Provide a succinct answer. 1.06. What is the ratio of the Value added (constant 2005 US$) of Industry in 2004 to that in 2008?
Your answer should be very brief. 0.97. What is the ratio of the Value added (constant 2005 US$) of Services in 2004 to that in 2008?
Give a very brief answer. 0.92. What is the ratio of the Value added (constant 2005 US$) in Industry in 2004 to that in 2009?
Offer a very short reply. 1.04. What is the ratio of the Value added (constant 2005 US$) of Services in 2004 to that in 2009?
Make the answer very short. 0.94. What is the ratio of the Value added (constant 2005 US$) in Agriculture in 2004 to that in 2009?
Provide a succinct answer. 0.88. What is the ratio of the Value added (constant 2005 US$) of Industry in 2005 to that in 2006?
Your answer should be compact. 0.97. What is the ratio of the Value added (constant 2005 US$) of Services in 2005 to that in 2006?
Ensure brevity in your answer.  0.98. What is the ratio of the Value added (constant 2005 US$) in Agriculture in 2005 to that in 2006?
Give a very brief answer. 0.96. What is the ratio of the Value added (constant 2005 US$) of Industry in 2005 to that in 2007?
Your answer should be very brief. 0.95. What is the ratio of the Value added (constant 2005 US$) of Services in 2005 to that in 2007?
Provide a short and direct response. 0.96. What is the ratio of the Value added (constant 2005 US$) in Agriculture in 2005 to that in 2007?
Your answer should be very brief. 1.11. What is the ratio of the Value added (constant 2005 US$) of Industry in 2005 to that in 2008?
Keep it short and to the point. 0.98. What is the ratio of the Value added (constant 2005 US$) in Services in 2005 to that in 2008?
Offer a terse response. 0.96. What is the ratio of the Value added (constant 2005 US$) of Agriculture in 2005 to that in 2008?
Keep it short and to the point. 1.04. What is the ratio of the Value added (constant 2005 US$) of Industry in 2005 to that in 2009?
Keep it short and to the point. 1.05. What is the ratio of the Value added (constant 2005 US$) in Agriculture in 2005 to that in 2009?
Provide a succinct answer. 0.92. What is the ratio of the Value added (constant 2005 US$) in Industry in 2006 to that in 2007?
Give a very brief answer. 0.98. What is the ratio of the Value added (constant 2005 US$) in Services in 2006 to that in 2007?
Make the answer very short. 0.98. What is the ratio of the Value added (constant 2005 US$) in Agriculture in 2006 to that in 2007?
Offer a terse response. 1.16. What is the ratio of the Value added (constant 2005 US$) of Industry in 2006 to that in 2008?
Your answer should be compact. 1.02. What is the ratio of the Value added (constant 2005 US$) in Services in 2006 to that in 2008?
Provide a short and direct response. 0.98. What is the ratio of the Value added (constant 2005 US$) of Agriculture in 2006 to that in 2008?
Keep it short and to the point. 1.09. What is the ratio of the Value added (constant 2005 US$) of Industry in 2006 to that in 2009?
Offer a terse response. 1.09. What is the ratio of the Value added (constant 2005 US$) of Services in 2006 to that in 2009?
Your answer should be very brief. 1. What is the ratio of the Value added (constant 2005 US$) of Agriculture in 2006 to that in 2009?
Provide a succinct answer. 0.96. What is the ratio of the Value added (constant 2005 US$) in Industry in 2007 to that in 2008?
Keep it short and to the point. 1.04. What is the ratio of the Value added (constant 2005 US$) of Agriculture in 2007 to that in 2008?
Ensure brevity in your answer.  0.94. What is the ratio of the Value added (constant 2005 US$) of Industry in 2007 to that in 2009?
Your response must be concise. 1.11. What is the ratio of the Value added (constant 2005 US$) in Agriculture in 2007 to that in 2009?
Make the answer very short. 0.83. What is the ratio of the Value added (constant 2005 US$) in Industry in 2008 to that in 2009?
Offer a very short reply. 1.07. What is the ratio of the Value added (constant 2005 US$) in Services in 2008 to that in 2009?
Ensure brevity in your answer.  1.02. What is the ratio of the Value added (constant 2005 US$) in Agriculture in 2008 to that in 2009?
Your answer should be very brief. 0.89. What is the difference between the highest and the second highest Value added (constant 2005 US$) of Industry?
Give a very brief answer. 5.56e+1. What is the difference between the highest and the second highest Value added (constant 2005 US$) in Services?
Ensure brevity in your answer.  2.54e+1. What is the difference between the highest and the second highest Value added (constant 2005 US$) in Agriculture?
Give a very brief answer. 6.85e+09. What is the difference between the highest and the lowest Value added (constant 2005 US$) in Industry?
Provide a succinct answer. 4.13e+11. What is the difference between the highest and the lowest Value added (constant 2005 US$) of Services?
Your answer should be very brief. 1.55e+12. What is the difference between the highest and the lowest Value added (constant 2005 US$) of Agriculture?
Provide a succinct answer. 4.78e+1. 